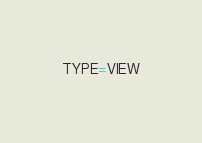Convert code to text. <code><loc_0><loc_0><loc_500><loc_500><_VisualBasic_>TYPE=VIEW</code> 